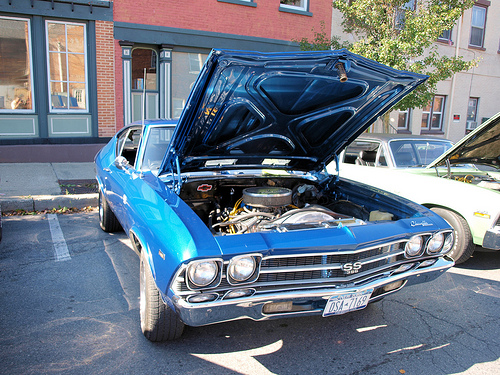<image>
Is the engine on the car? No. The engine is not positioned on the car. They may be near each other, but the engine is not supported by or resting on top of the car. 